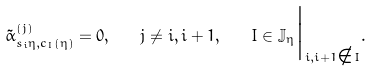<formula> <loc_0><loc_0><loc_500><loc_500>\tilde { \alpha } _ { s _ { i } \eta , c _ { I } ( \eta ) } ^ { ( j ) } = 0 , \quad j \ne i , i + 1 , \quad I \in \mathbb { J } _ { \eta } \Big | _ { i , i + 1 \notin I } .</formula> 